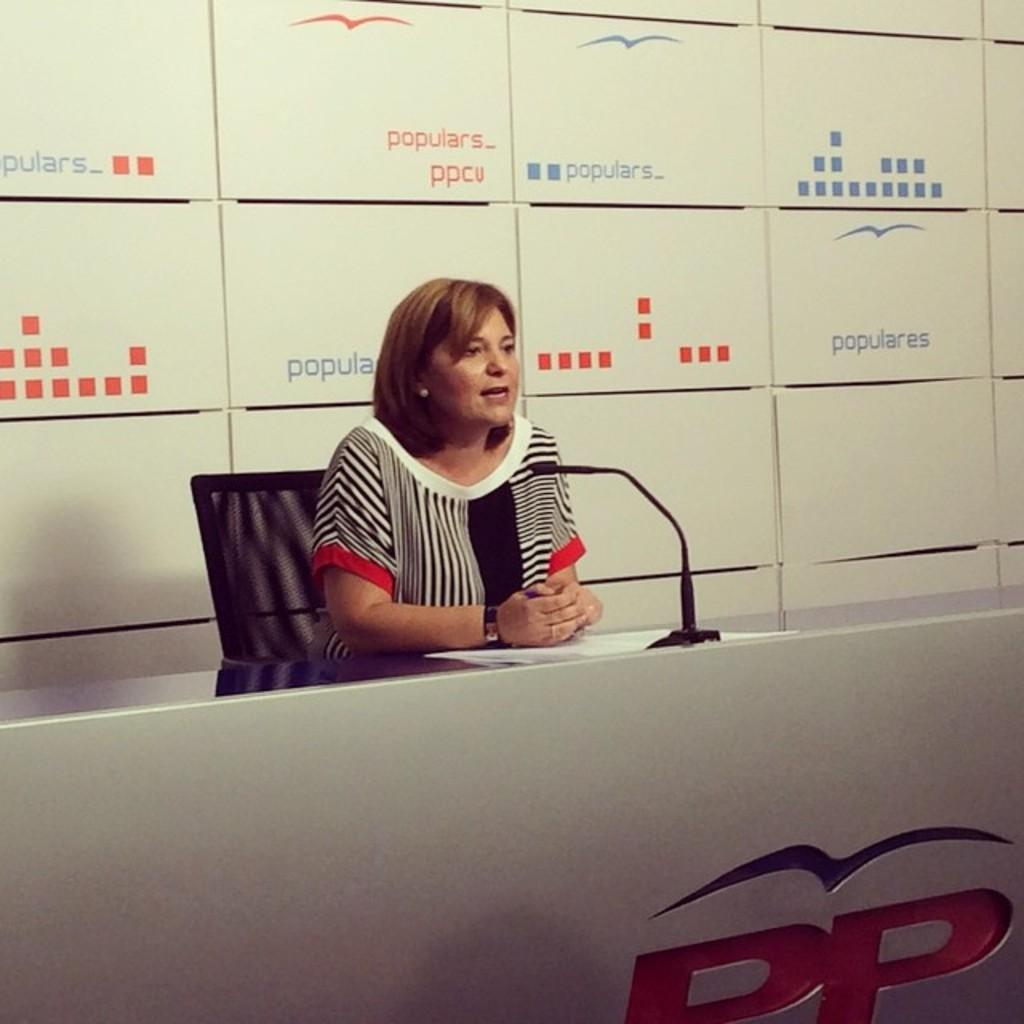Who is the main subject in the image? There is a lady in the image. Where is the lady located in the image? The lady is sitting at the center of the image. What is the lady sitting on? The lady is sitting on a chair. What is the lady doing with her hands? The lady is resting her hands on a table. What object is in front of the lady? There is a microphone (mic) in front of the lady. What type of rose is the lady holding in her hand? There is no rose present in the image; the lady is resting her hands on a table. 